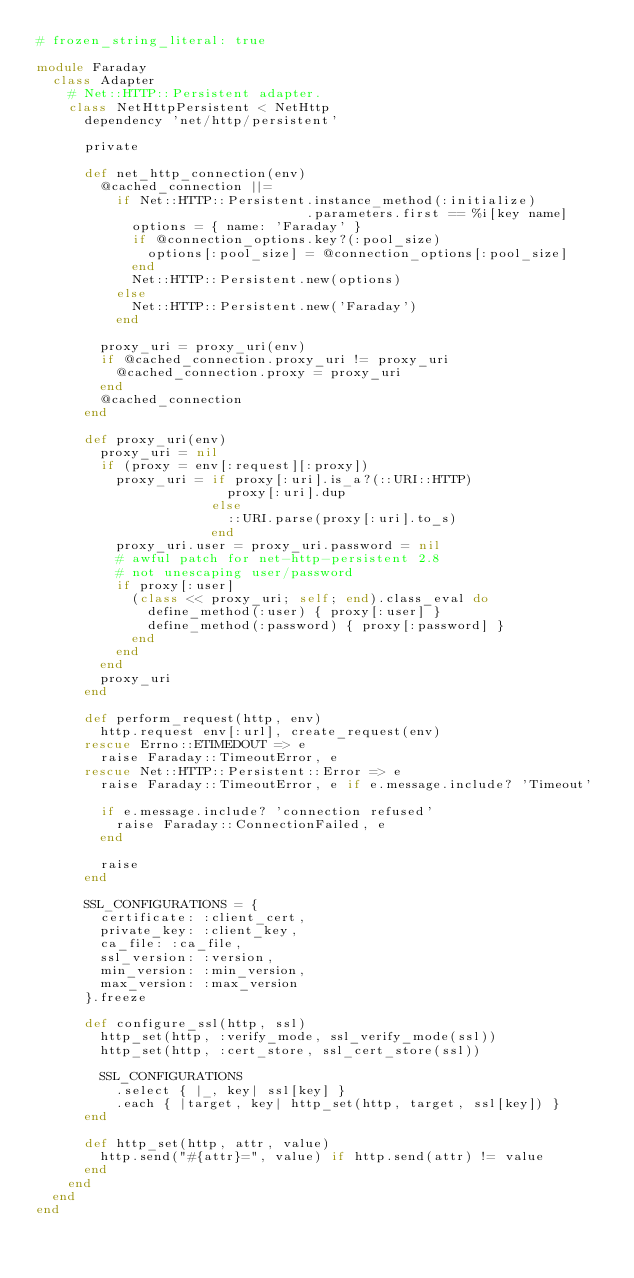<code> <loc_0><loc_0><loc_500><loc_500><_Ruby_># frozen_string_literal: true

module Faraday
  class Adapter
    # Net::HTTP::Persistent adapter.
    class NetHttpPersistent < NetHttp
      dependency 'net/http/persistent'

      private

      def net_http_connection(env)
        @cached_connection ||=
          if Net::HTTP::Persistent.instance_method(:initialize)
                                  .parameters.first == %i[key name]
            options = { name: 'Faraday' }
            if @connection_options.key?(:pool_size)
              options[:pool_size] = @connection_options[:pool_size]
            end
            Net::HTTP::Persistent.new(options)
          else
            Net::HTTP::Persistent.new('Faraday')
          end

        proxy_uri = proxy_uri(env)
        if @cached_connection.proxy_uri != proxy_uri
          @cached_connection.proxy = proxy_uri
        end
        @cached_connection
      end

      def proxy_uri(env)
        proxy_uri = nil
        if (proxy = env[:request][:proxy])
          proxy_uri = if proxy[:uri].is_a?(::URI::HTTP)
                        proxy[:uri].dup
                      else
                        ::URI.parse(proxy[:uri].to_s)
                      end
          proxy_uri.user = proxy_uri.password = nil
          # awful patch for net-http-persistent 2.8
          # not unescaping user/password
          if proxy[:user]
            (class << proxy_uri; self; end).class_eval do
              define_method(:user) { proxy[:user] }
              define_method(:password) { proxy[:password] }
            end
          end
        end
        proxy_uri
      end

      def perform_request(http, env)
        http.request env[:url], create_request(env)
      rescue Errno::ETIMEDOUT => e
        raise Faraday::TimeoutError, e
      rescue Net::HTTP::Persistent::Error => e
        raise Faraday::TimeoutError, e if e.message.include? 'Timeout'

        if e.message.include? 'connection refused'
          raise Faraday::ConnectionFailed, e
        end

        raise
      end

      SSL_CONFIGURATIONS = {
        certificate: :client_cert,
        private_key: :client_key,
        ca_file: :ca_file,
        ssl_version: :version,
        min_version: :min_version,
        max_version: :max_version
      }.freeze

      def configure_ssl(http, ssl)
        http_set(http, :verify_mode, ssl_verify_mode(ssl))
        http_set(http, :cert_store, ssl_cert_store(ssl))

        SSL_CONFIGURATIONS
          .select { |_, key| ssl[key] }
          .each { |target, key| http_set(http, target, ssl[key]) }
      end

      def http_set(http, attr, value)
        http.send("#{attr}=", value) if http.send(attr) != value
      end
    end
  end
end
</code> 